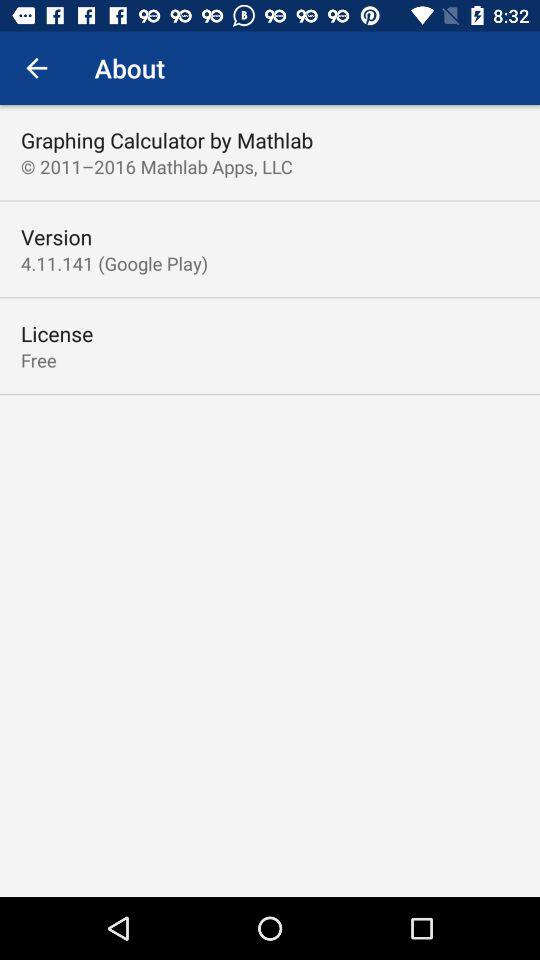What is the current version? The current version is 4.11.141. 